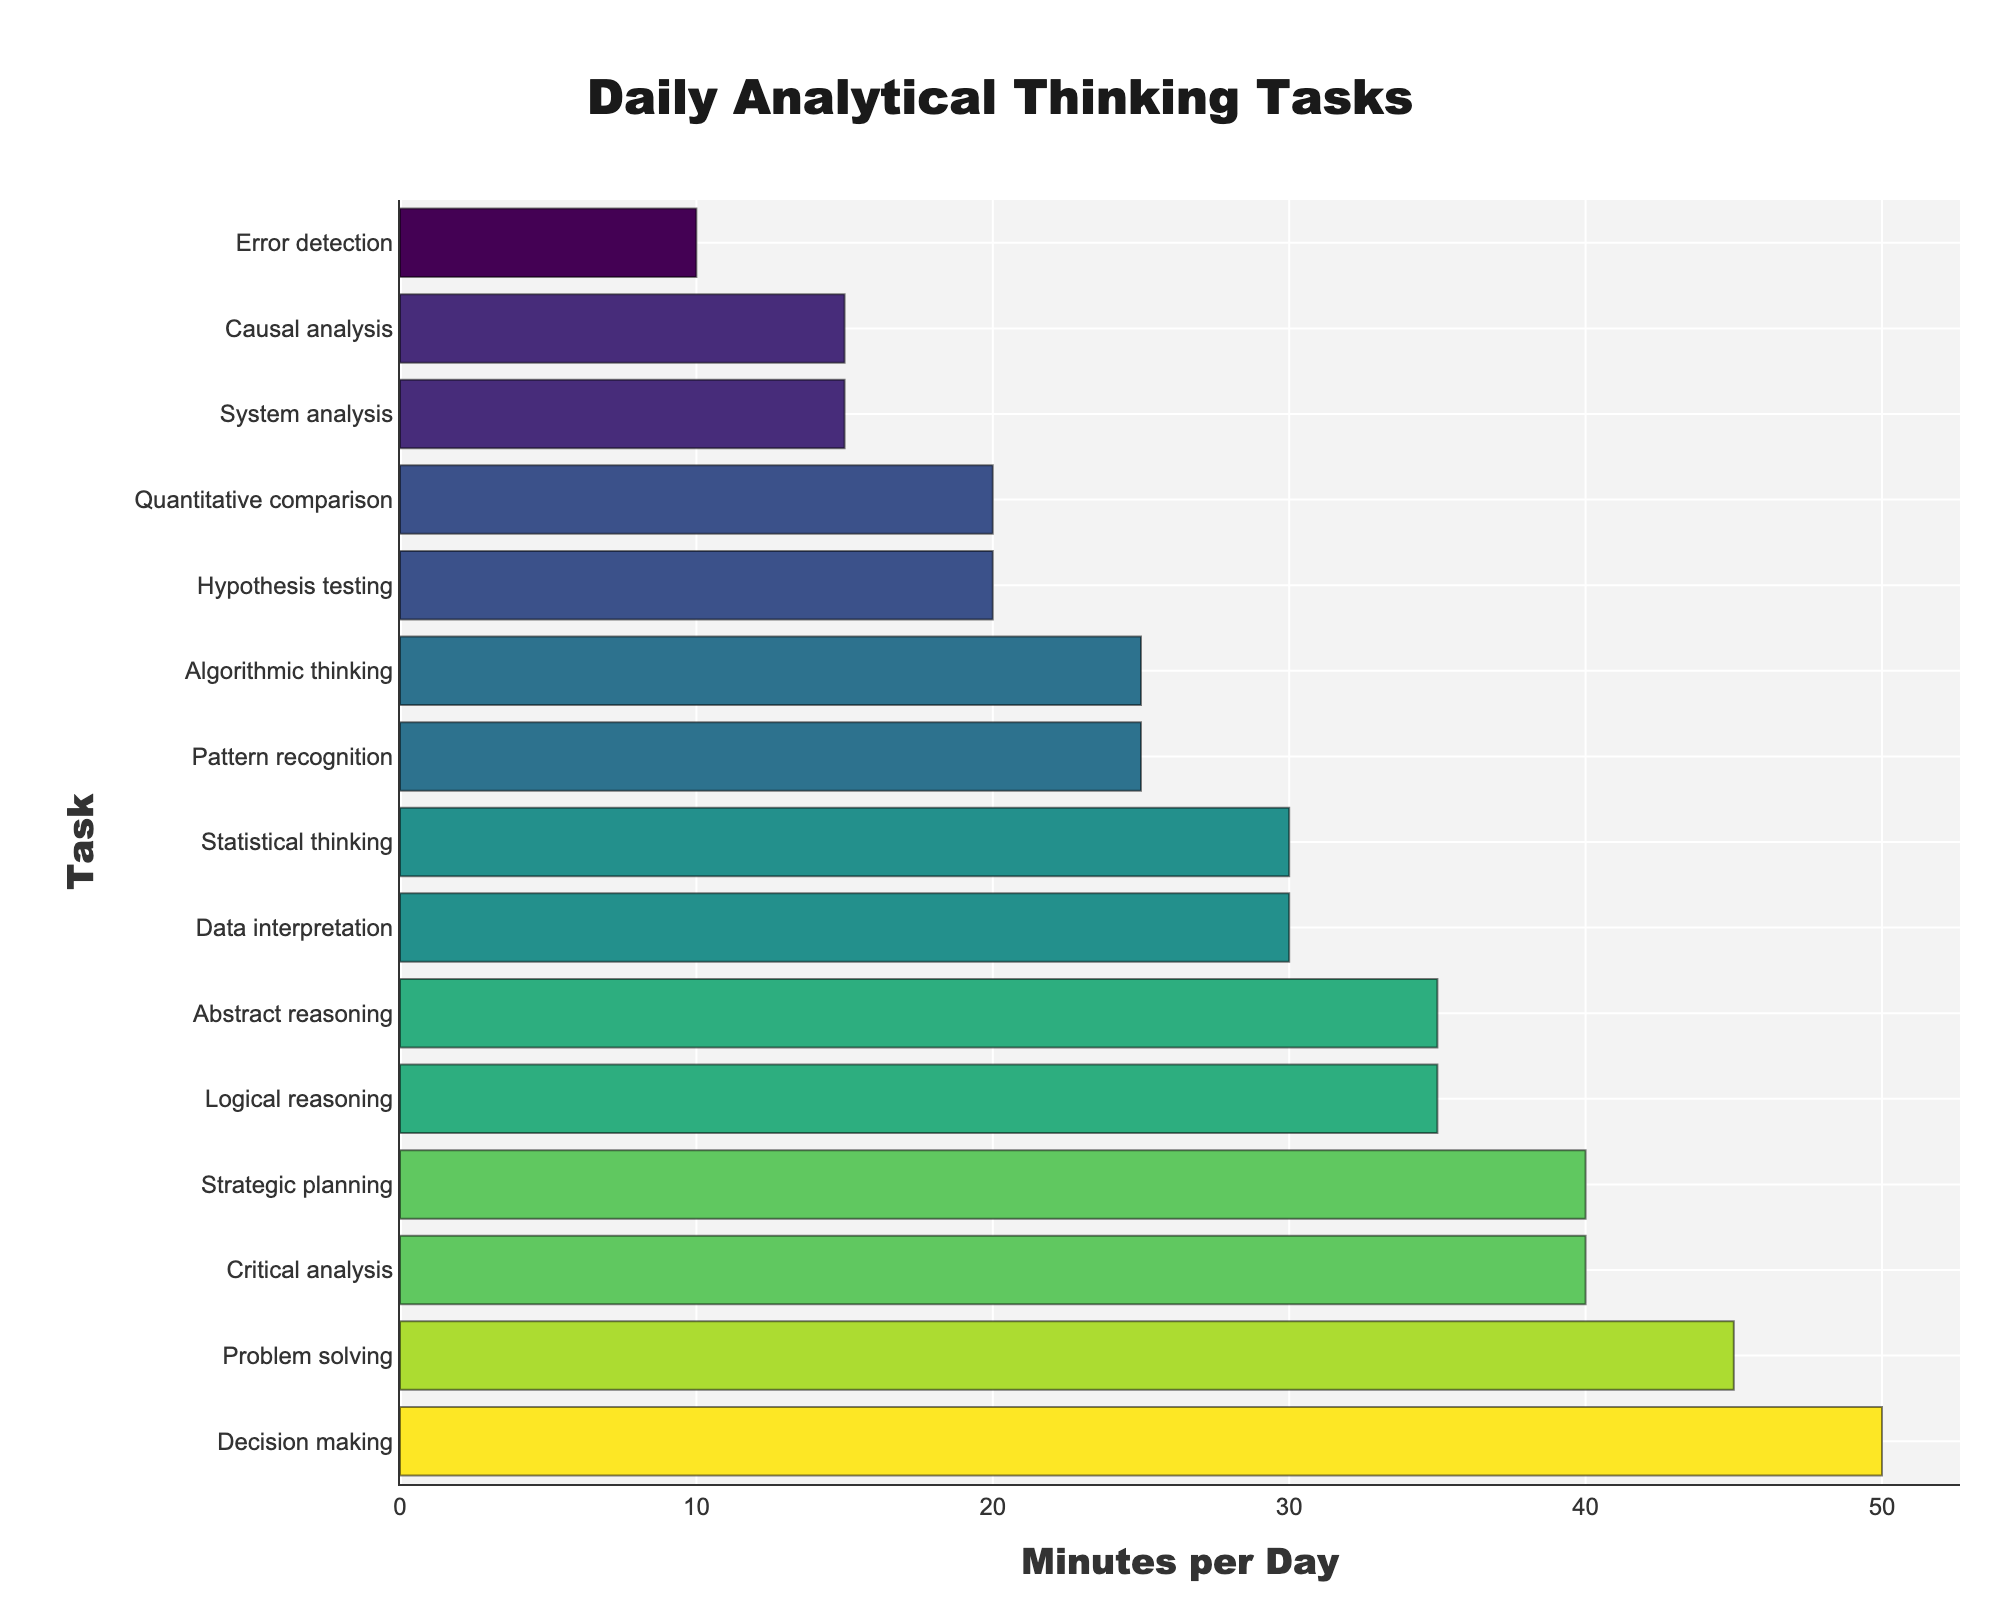What's the average time spent per task? To find the average, first sum all the given minutes (45 + 30 + 35 + 40 + 25 + 20 + 30 + 50 + 15 + 20 + 25 + 35 + 15 + 40 + 10 = 435). Next, divide by the total number of tasks (435/15).
Answer: 29 minutes Which task has the highest time spent and how many minutes is it? By examining the data, Decision making has the highest time allocation with 50 minutes.
Answer: Decision making, 50 minutes How much more time is spent on Decision making compared to System analysis? Decision making is allocated 50 minutes whereas System analysis is allocated 15 minutes. The difference is 50 - 15 = 35.
Answer: 35 minutes What is the total time spent on tasks with 'analysis' in their names? Sum the minutes for Critical analysis (40), System analysis (15), and Causal analysis (15). The total is 40 + 15 + 15 = 70.
Answer: 70 minutes Which task is represented by the shortest bar and what is its time allocation? Error detection has the shortest bar with a time allocation of 10 minutes.
Answer: Error detection, 10 minutes How many tasks require 30 minutes or more? The tasks with 30 or more minutes are Problem solving (45), Logical reasoning (35), Critical analysis (40), Statistical thinking (30), Decision making (50), and Abstract reasoning (35). There are 6 such tasks.
Answer: 6 tasks Compare the time spent on Hypothesis testing and Pattern recognition. Which one is greater and by how much? Hypothesis testing is allocated 20 minutes and Pattern recognition is allocated 25 minutes. Pattern recognition has 5 more minutes (25 - 20).
Answer: Pattern recognition by 5 minutes What is the median time spent on the tasks? To find the median, first list the times in ascending order: 10, 15, 15, 20, 20, 25, 25, 30, 30, 35, 35, 40, 40, 45, 50. The median is the middle value, which is the 8th value: 30 minutes.
Answer: 30 minutes What is the combined time spent on Problem solving and Decision making? Problem solving is allocated 45 minutes and Decision making is allocated 50 minutes. Summing these gives 45 + 50 = 95.
Answer: 95 minutes Which task uses the most visually prominent (darkest) color bar and what is the time allocated to this task? Decision making uses the most visually prominent bar as it has the highest time allocation of 50 minutes, which corresponds to the darkest color in the Viridis color scale.
Answer: Decision making, 50 minutes 